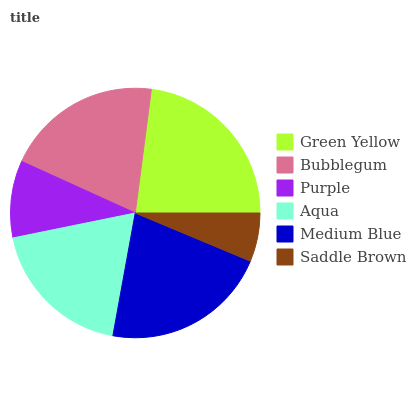Is Saddle Brown the minimum?
Answer yes or no. Yes. Is Green Yellow the maximum?
Answer yes or no. Yes. Is Bubblegum the minimum?
Answer yes or no. No. Is Bubblegum the maximum?
Answer yes or no. No. Is Green Yellow greater than Bubblegum?
Answer yes or no. Yes. Is Bubblegum less than Green Yellow?
Answer yes or no. Yes. Is Bubblegum greater than Green Yellow?
Answer yes or no. No. Is Green Yellow less than Bubblegum?
Answer yes or no. No. Is Bubblegum the high median?
Answer yes or no. Yes. Is Aqua the low median?
Answer yes or no. Yes. Is Medium Blue the high median?
Answer yes or no. No. Is Saddle Brown the low median?
Answer yes or no. No. 